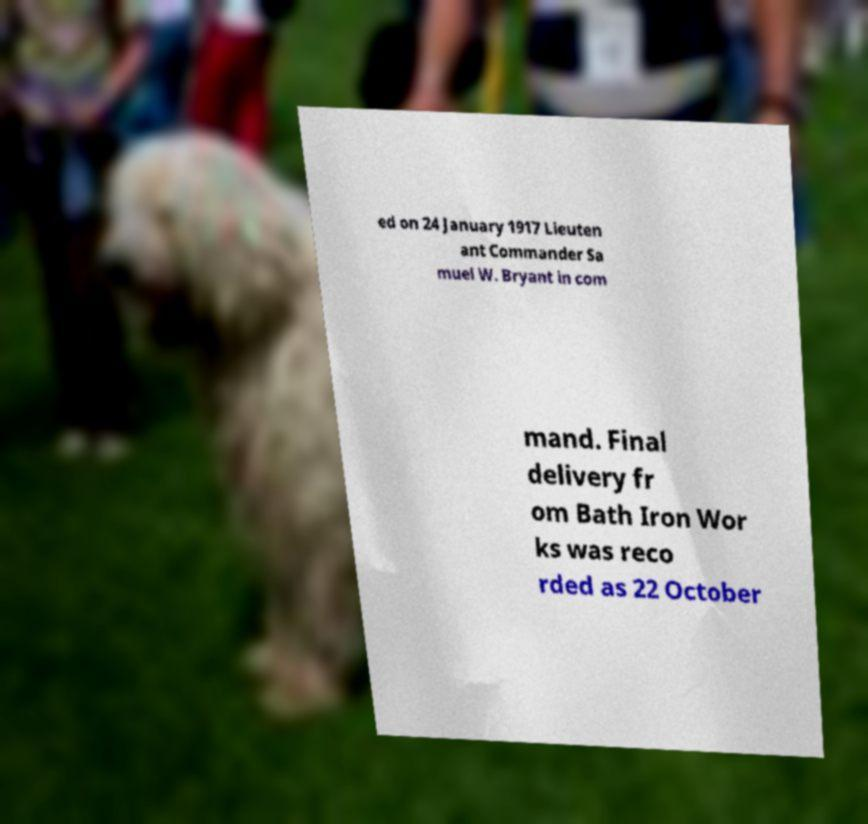Could you assist in decoding the text presented in this image and type it out clearly? ed on 24 January 1917 Lieuten ant Commander Sa muel W. Bryant in com mand. Final delivery fr om Bath Iron Wor ks was reco rded as 22 October 